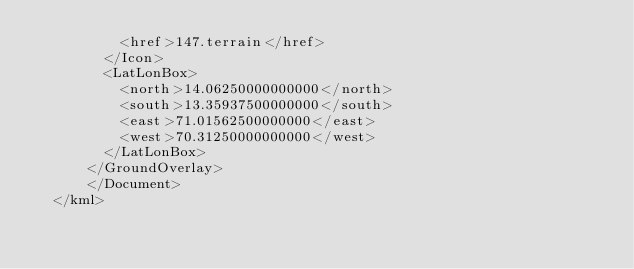Convert code to text. <code><loc_0><loc_0><loc_500><loc_500><_XML_>	        <href>147.terrain</href>
	      </Icon>
	      <LatLonBox>
	        <north>14.06250000000000</north>
	        <south>13.35937500000000</south>
	        <east>71.01562500000000</east>
	        <west>70.31250000000000</west>
	      </LatLonBox>
	    </GroundOverlay>
		  </Document>
	</kml>
	</code> 